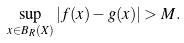<formula> <loc_0><loc_0><loc_500><loc_500>\sup _ { x \in B _ { R } ( X ) } | f ( x ) - g ( x ) | > M .</formula> 